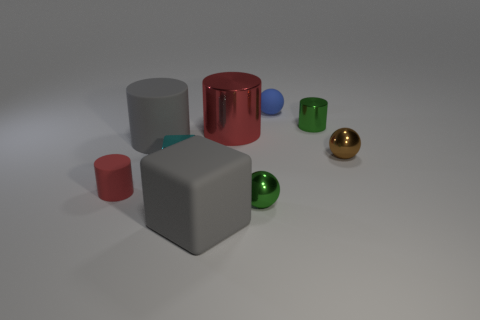There is a gray matte thing in front of the tiny brown thing; how many gray matte blocks are left of it?
Ensure brevity in your answer.  0. Is there a tiny rubber ball that has the same color as the small rubber cylinder?
Provide a short and direct response. No. Is the green shiny cylinder the same size as the blue object?
Provide a succinct answer. Yes. Does the small matte sphere have the same color as the small metallic cylinder?
Your response must be concise. No. There is a block in front of the tiny green metal thing in front of the gray cylinder; what is its material?
Your response must be concise. Rubber. What is the material of the other object that is the same shape as the cyan metal object?
Your answer should be compact. Rubber. There is a cube that is right of the cyan metallic object; does it have the same size as the small shiny cylinder?
Offer a very short reply. No. How many metallic things are large blue blocks or small cyan cubes?
Offer a very short reply. 1. What material is the small ball that is both behind the small red matte object and in front of the large red object?
Your answer should be very brief. Metal. Do the tiny red cylinder and the tiny brown thing have the same material?
Give a very brief answer. No. 